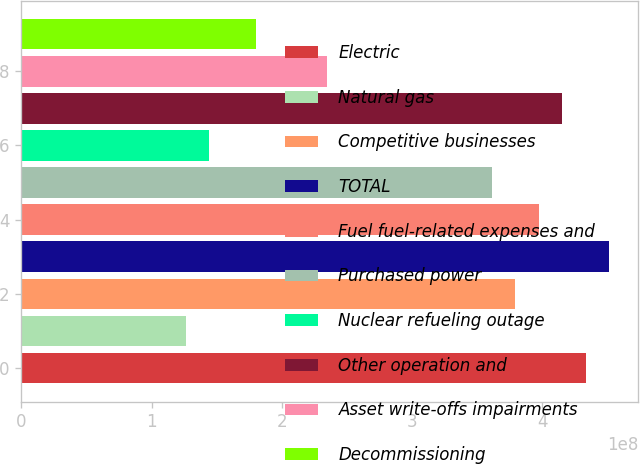<chart> <loc_0><loc_0><loc_500><loc_500><bar_chart><fcel>Electric<fcel>Natural gas<fcel>Competitive businesses<fcel>TOTAL<fcel>Fuel fuel-related expenses and<fcel>Purchased power<fcel>Nuclear refueling outage<fcel>Other operation and<fcel>Asset write-offs impairments<fcel>Decommissioning<nl><fcel>4.33286e+08<fcel>1.26375e+08<fcel>3.79125e+08<fcel>4.5134e+08<fcel>3.97179e+08<fcel>3.61072e+08<fcel>1.44429e+08<fcel>4.15233e+08<fcel>2.34697e+08<fcel>1.80536e+08<nl></chart> 